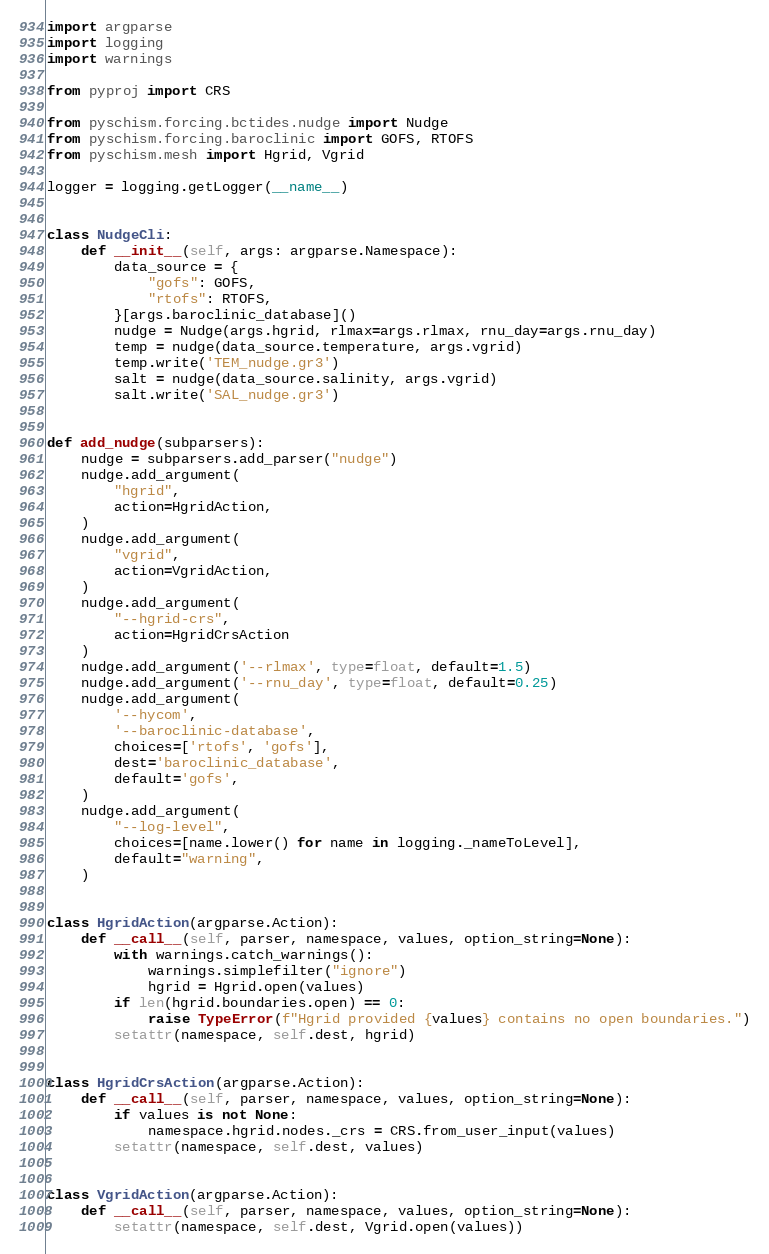Convert code to text. <code><loc_0><loc_0><loc_500><loc_500><_Python_>import argparse
import logging
import warnings

from pyproj import CRS

from pyschism.forcing.bctides.nudge import Nudge
from pyschism.forcing.baroclinic import GOFS, RTOFS
from pyschism.mesh import Hgrid, Vgrid

logger = logging.getLogger(__name__)


class NudgeCli:
    def __init__(self, args: argparse.Namespace):
        data_source = {
            "gofs": GOFS,
            "rtofs": RTOFS,
        }[args.baroclinic_database]()
        nudge = Nudge(args.hgrid, rlmax=args.rlmax, rnu_day=args.rnu_day)
        temp = nudge(data_source.temperature, args.vgrid)
        temp.write('TEM_nudge.gr3')
        salt = nudge(data_source.salinity, args.vgrid)
        salt.write('SAL_nudge.gr3')


def add_nudge(subparsers):
    nudge = subparsers.add_parser("nudge")
    nudge.add_argument(
        "hgrid",
        action=HgridAction,
    )
    nudge.add_argument(
        "vgrid",
        action=VgridAction,
    )
    nudge.add_argument(
        "--hgrid-crs",
        action=HgridCrsAction
    )
    nudge.add_argument('--rlmax', type=float, default=1.5)
    nudge.add_argument('--rnu_day', type=float, default=0.25)
    nudge.add_argument(
        '--hycom',
        '--baroclinic-database',
        choices=['rtofs', 'gofs'],
        dest='baroclinic_database',
        default='gofs',
    )
    nudge.add_argument(
        "--log-level",
        choices=[name.lower() for name in logging._nameToLevel],
        default="warning",
    )


class HgridAction(argparse.Action):
    def __call__(self, parser, namespace, values, option_string=None):
        with warnings.catch_warnings():
            warnings.simplefilter("ignore")
            hgrid = Hgrid.open(values)
        if len(hgrid.boundaries.open) == 0:
            raise TypeError(f"Hgrid provided {values} contains no open boundaries.")
        setattr(namespace, self.dest, hgrid)


class HgridCrsAction(argparse.Action):
    def __call__(self, parser, namespace, values, option_string=None):
        if values is not None:
            namespace.hgrid.nodes._crs = CRS.from_user_input(values)
        setattr(namespace, self.dest, values)


class VgridAction(argparse.Action):
    def __call__(self, parser, namespace, values, option_string=None):
        setattr(namespace, self.dest, Vgrid.open(values))
</code> 